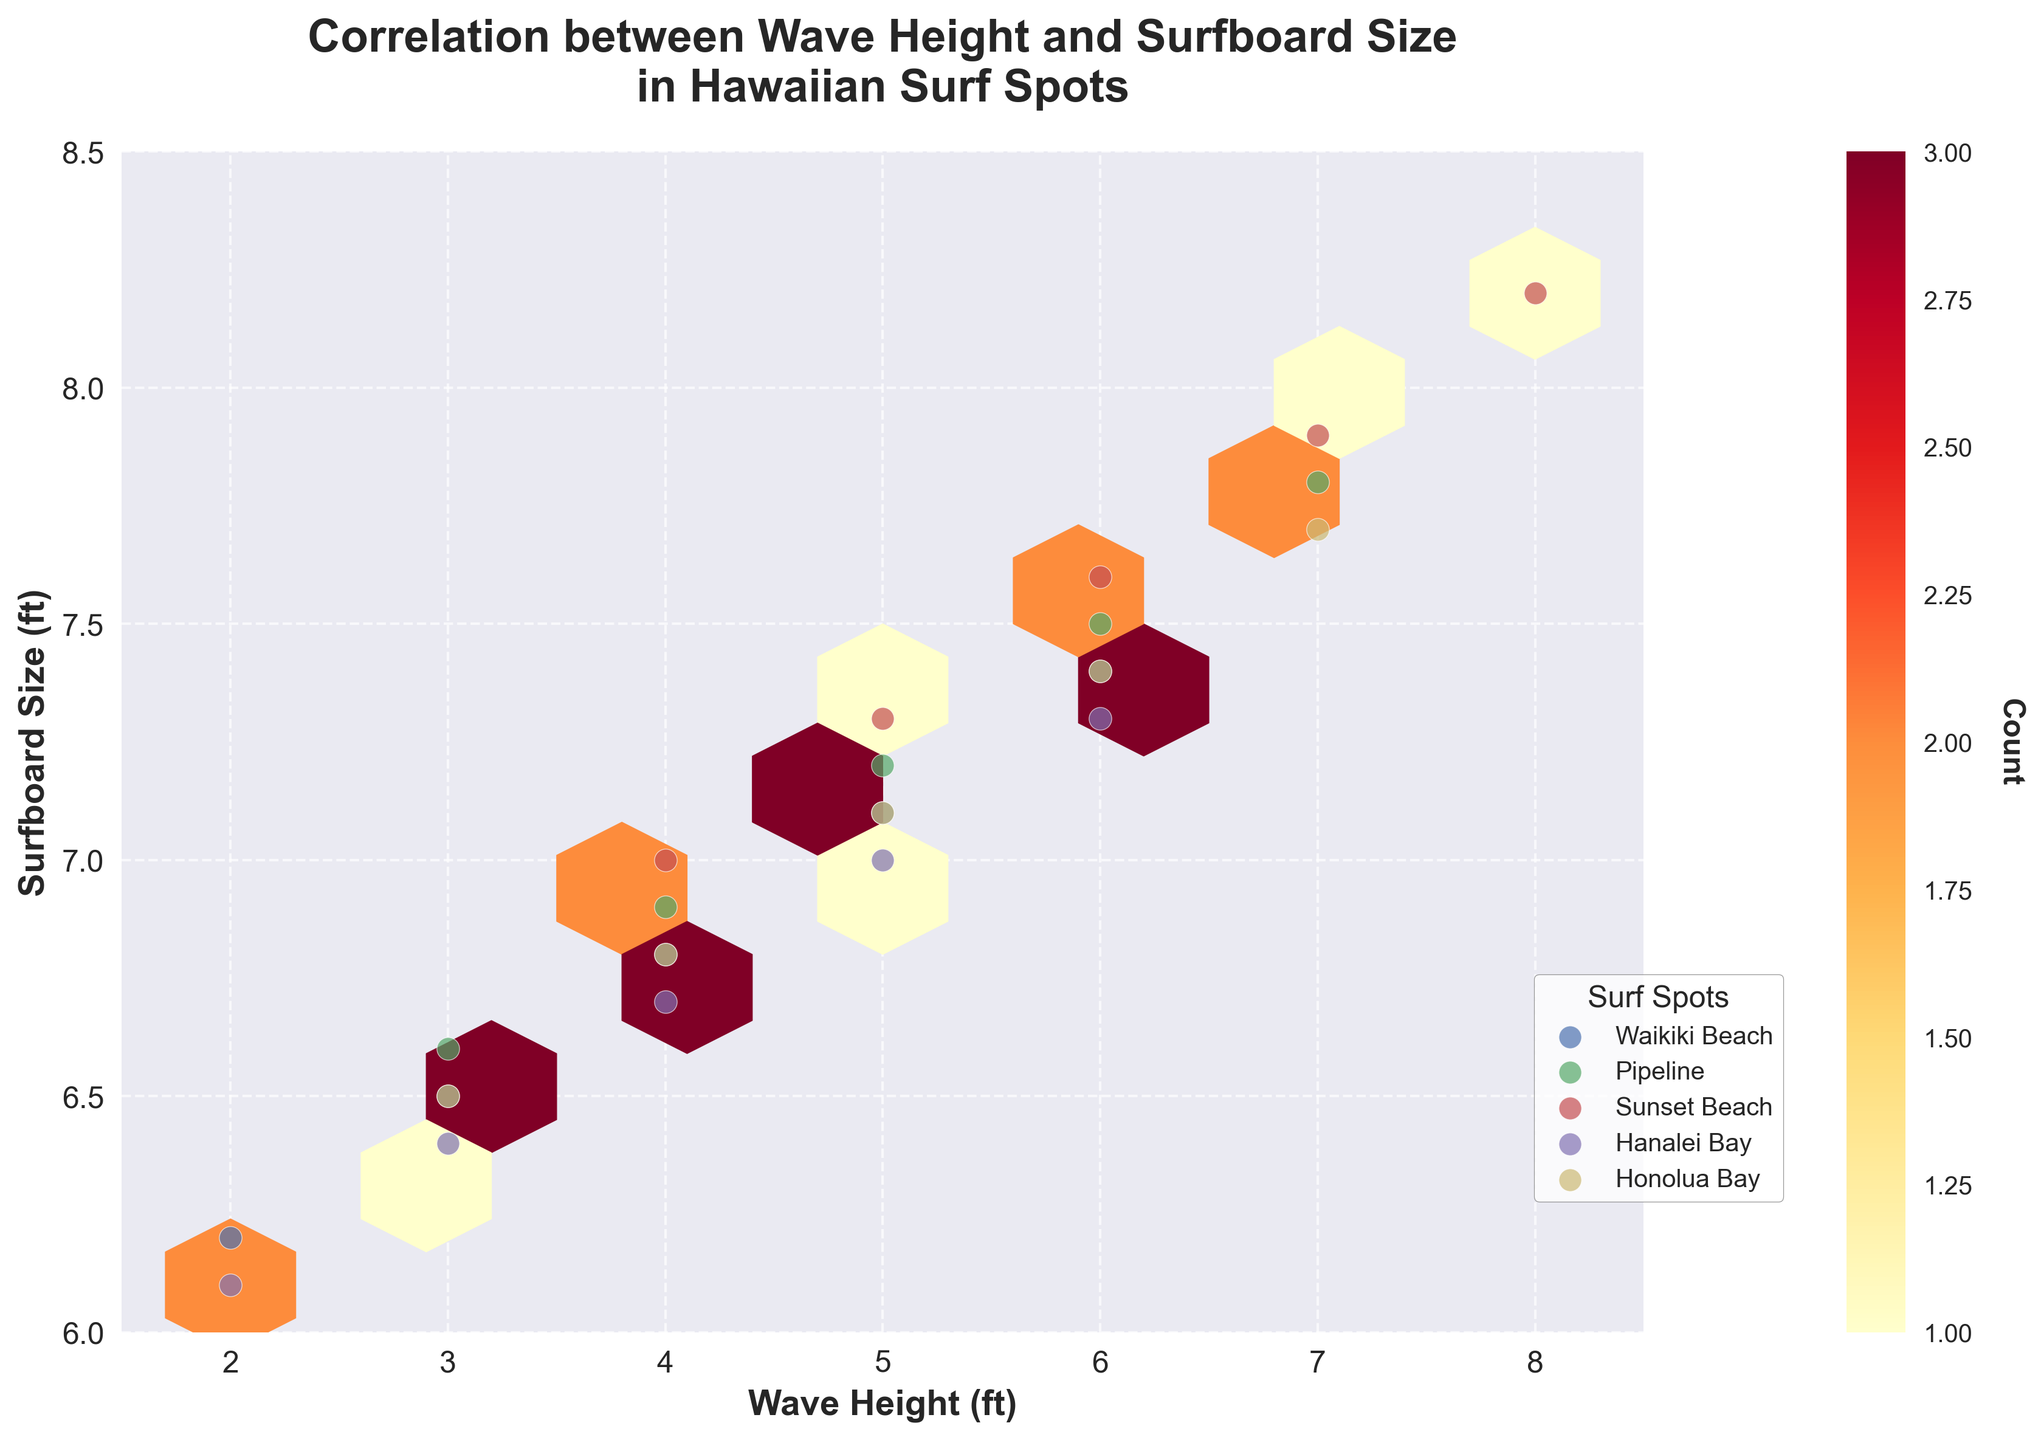What is the title of the plot? The title is displayed at the top of the plot. It reads "Correlation between Wave Height and Surfboard Size in Hawaiian Surf Spots".
Answer: Correlation between Wave Height and Surfboard Size in Hawaiian Surf Spots What are the axes labels? The labels for the axes are shown along each axis. The x-axis is labeled "Wave Height (ft)" and the y-axis is labeled "Surfboard Size (ft)".
Answer: Wave Height (ft) and Surfboard Size (ft) How many hexagons have a count of at least one? By visually inspecting the hexbin plot, you can see the hexagons shaded in different colors. Each hexagon colored in the plot represents at least one count. Count the number of such hexagons.
Answer: 8 Which surf spot is represented as having the highest wave height? By looking at the scatter points overlaid on the hexbin plot, find the maximum value on the x-axis (Wave Height) that accompanies the labeled surf spot. Sunset Beach has the highest wave heights.
Answer: Sunset Beach How does the correlation between wave height and surfboard size appear? By examining the overall pattern of hexagons, you notice a positive correlation, indicated by the trend in the hexagon colors moving upwards and to the right as wave height increases.
Answer: Positive correlation Which surf spot has a data point with the surfboard size of 8.2 ft? By looking at the scatter points overlaid on the hexbin plot, check for the one with a y-coordinate of 8.2 ft. The label indicates that it's Sunset Beach.
Answer: Sunset Beach How many color bar levels are shown in the figure? The color bar, which usually appears on the side of the figure, has distinct color levels representing the hexagon counts. Count the number of distinct levels displayed.
Answer: 5 Which surf spot shows the most variation in the surfboard sizes? By observing the scatter points over the y-axis, note which surf spot has the widest spread in surfboard size values. Sunset Beach has the widest spread in surfboard size.
Answer: Sunset Beach What is the grid size used in the hexbin plot? Grid size determines the number of hexagons used in the plot. Referring to the details in the question, the grid size used is 10.
Answer: 10 Compare the wave height and surfboard size for Waikiki Beach and Pipeline. Which has a higher maximum surfboard size? Looking at the scatter points for Waikiki Beach and Pipeline, observe that the highest surfboard sizes for each are 7.4 ft and 7.8 ft respectively. Pipeline has a higher maximum surfboard size.
Answer: Pipeline 